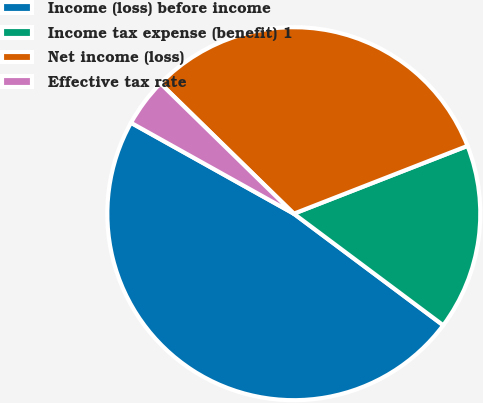Convert chart to OTSL. <chart><loc_0><loc_0><loc_500><loc_500><pie_chart><fcel>Income (loss) before income<fcel>Income tax expense (benefit) 1<fcel>Net income (loss)<fcel>Effective tax rate<nl><fcel>47.89%<fcel>16.13%<fcel>31.76%<fcel>4.21%<nl></chart> 